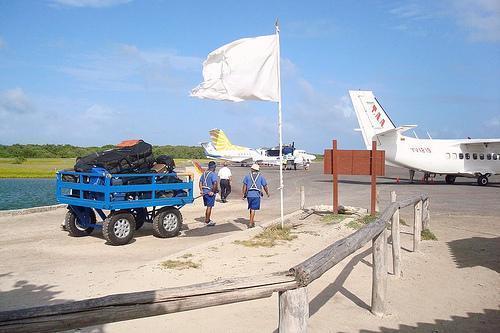How many men are wearing vests?
Give a very brief answer. 2. How many flags are in the photo?
Give a very brief answer. 1. How many blue hard hats are there?
Give a very brief answer. 0. 